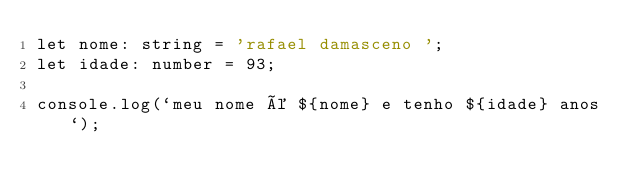Convert code to text. <code><loc_0><loc_0><loc_500><loc_500><_TypeScript_>let nome: string = 'rafael damasceno ';
let idade: number = 93;

console.log(`meu nome é ${nome} e tenho ${idade} anos`);
</code> 